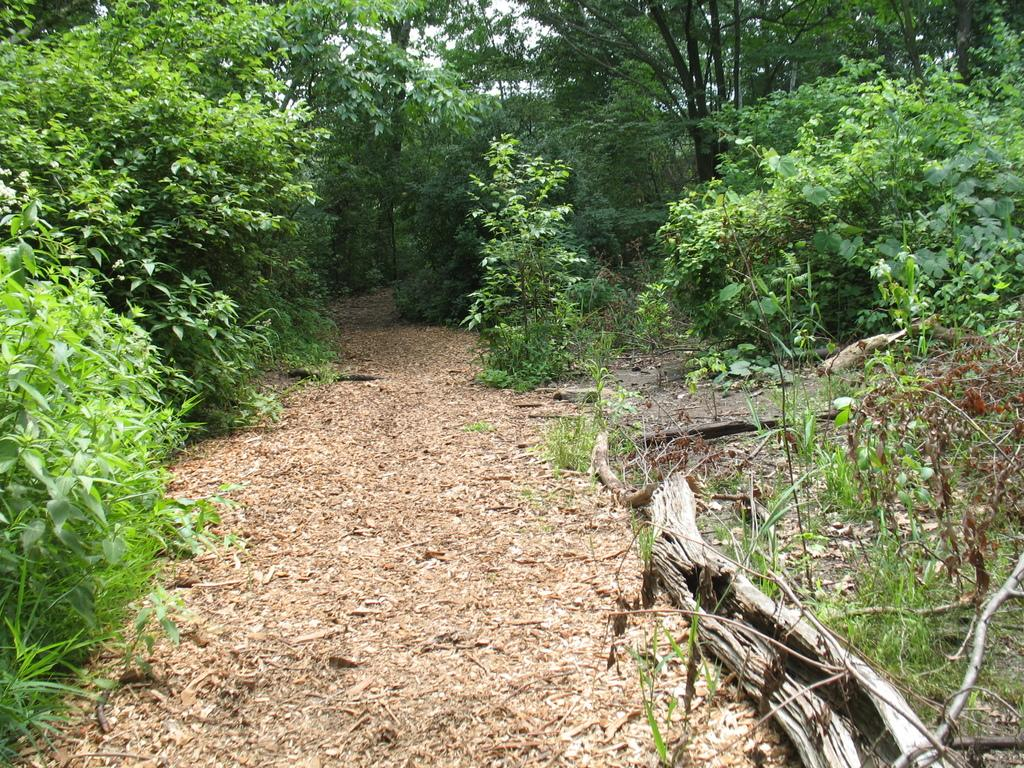What type of natural material can be seen on the land in the image? There are dry leaves on the land in the image. What part of a tree is visible in the image? The bark of a tree is visible in the image. How many trees can be seen in the image? There are trees in the image. What type of base is used for the cream in the image? There is no cream or base present in the image; it features dry leaves on the land and the bark of a tree. Can you describe how the trees walk in the image? Trees do not walk; they are stationary in the image. 